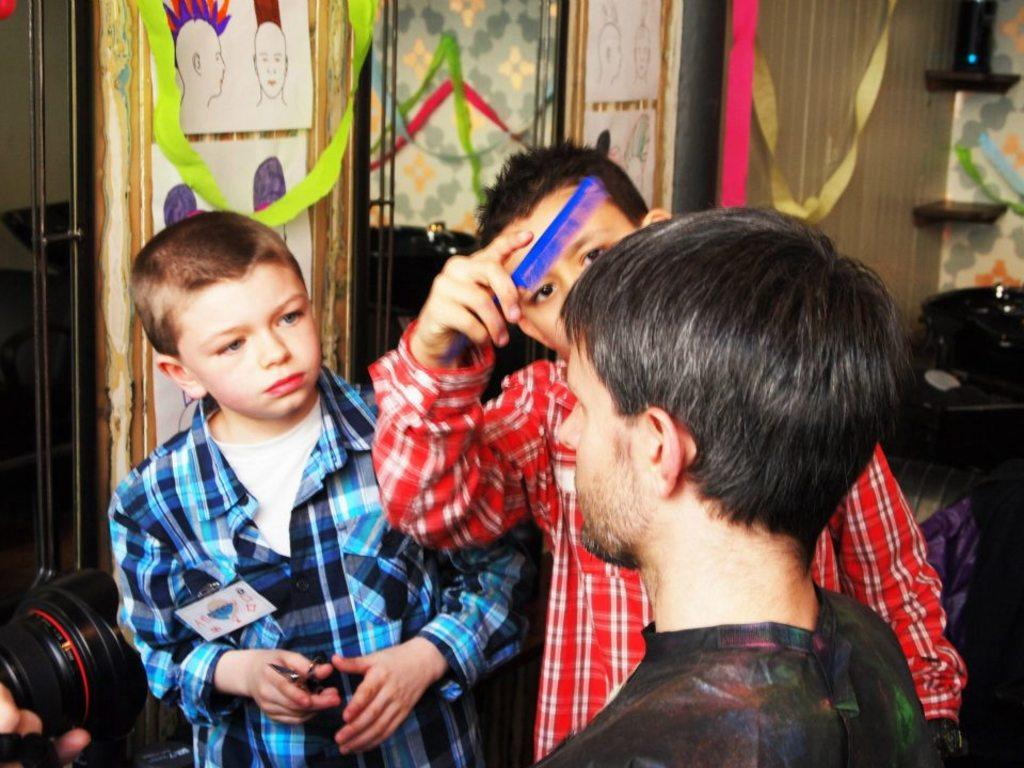How many people are in the image? There are three persons standing near the camera. What can be seen in the background of the image? There are paper ribbons, frames attached to the wall, and a couch in the background. What type of cat is sitting on the couch in the image? There is no cat present in the image; only the three persons, paper ribbons, frames, and couch are visible. 